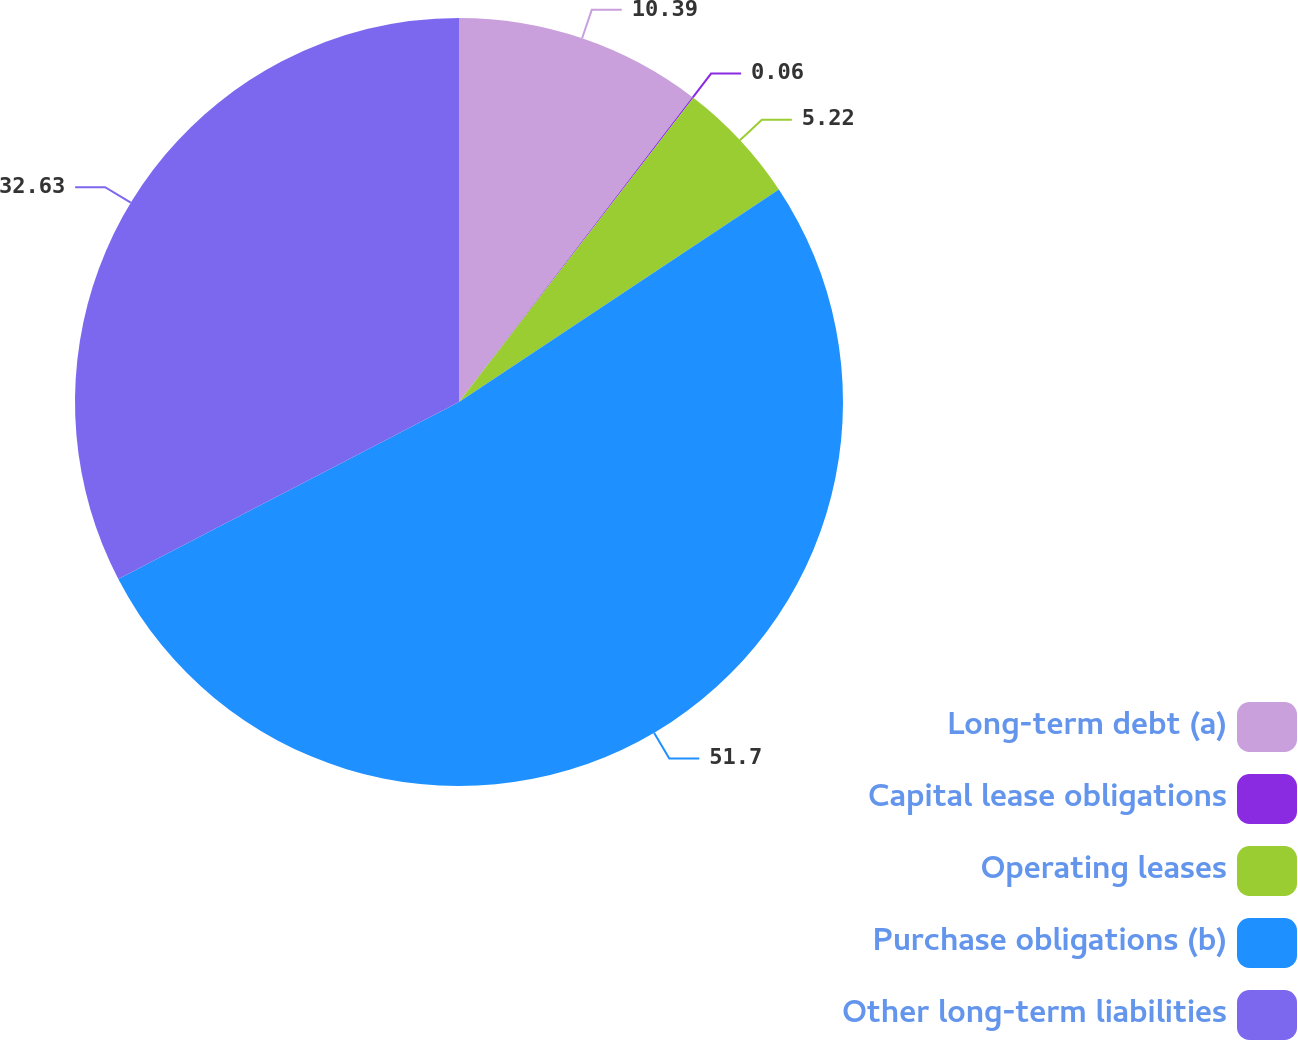Convert chart to OTSL. <chart><loc_0><loc_0><loc_500><loc_500><pie_chart><fcel>Long-term debt (a)<fcel>Capital lease obligations<fcel>Operating leases<fcel>Purchase obligations (b)<fcel>Other long-term liabilities<nl><fcel>10.39%<fcel>0.06%<fcel>5.22%<fcel>51.7%<fcel>32.63%<nl></chart> 